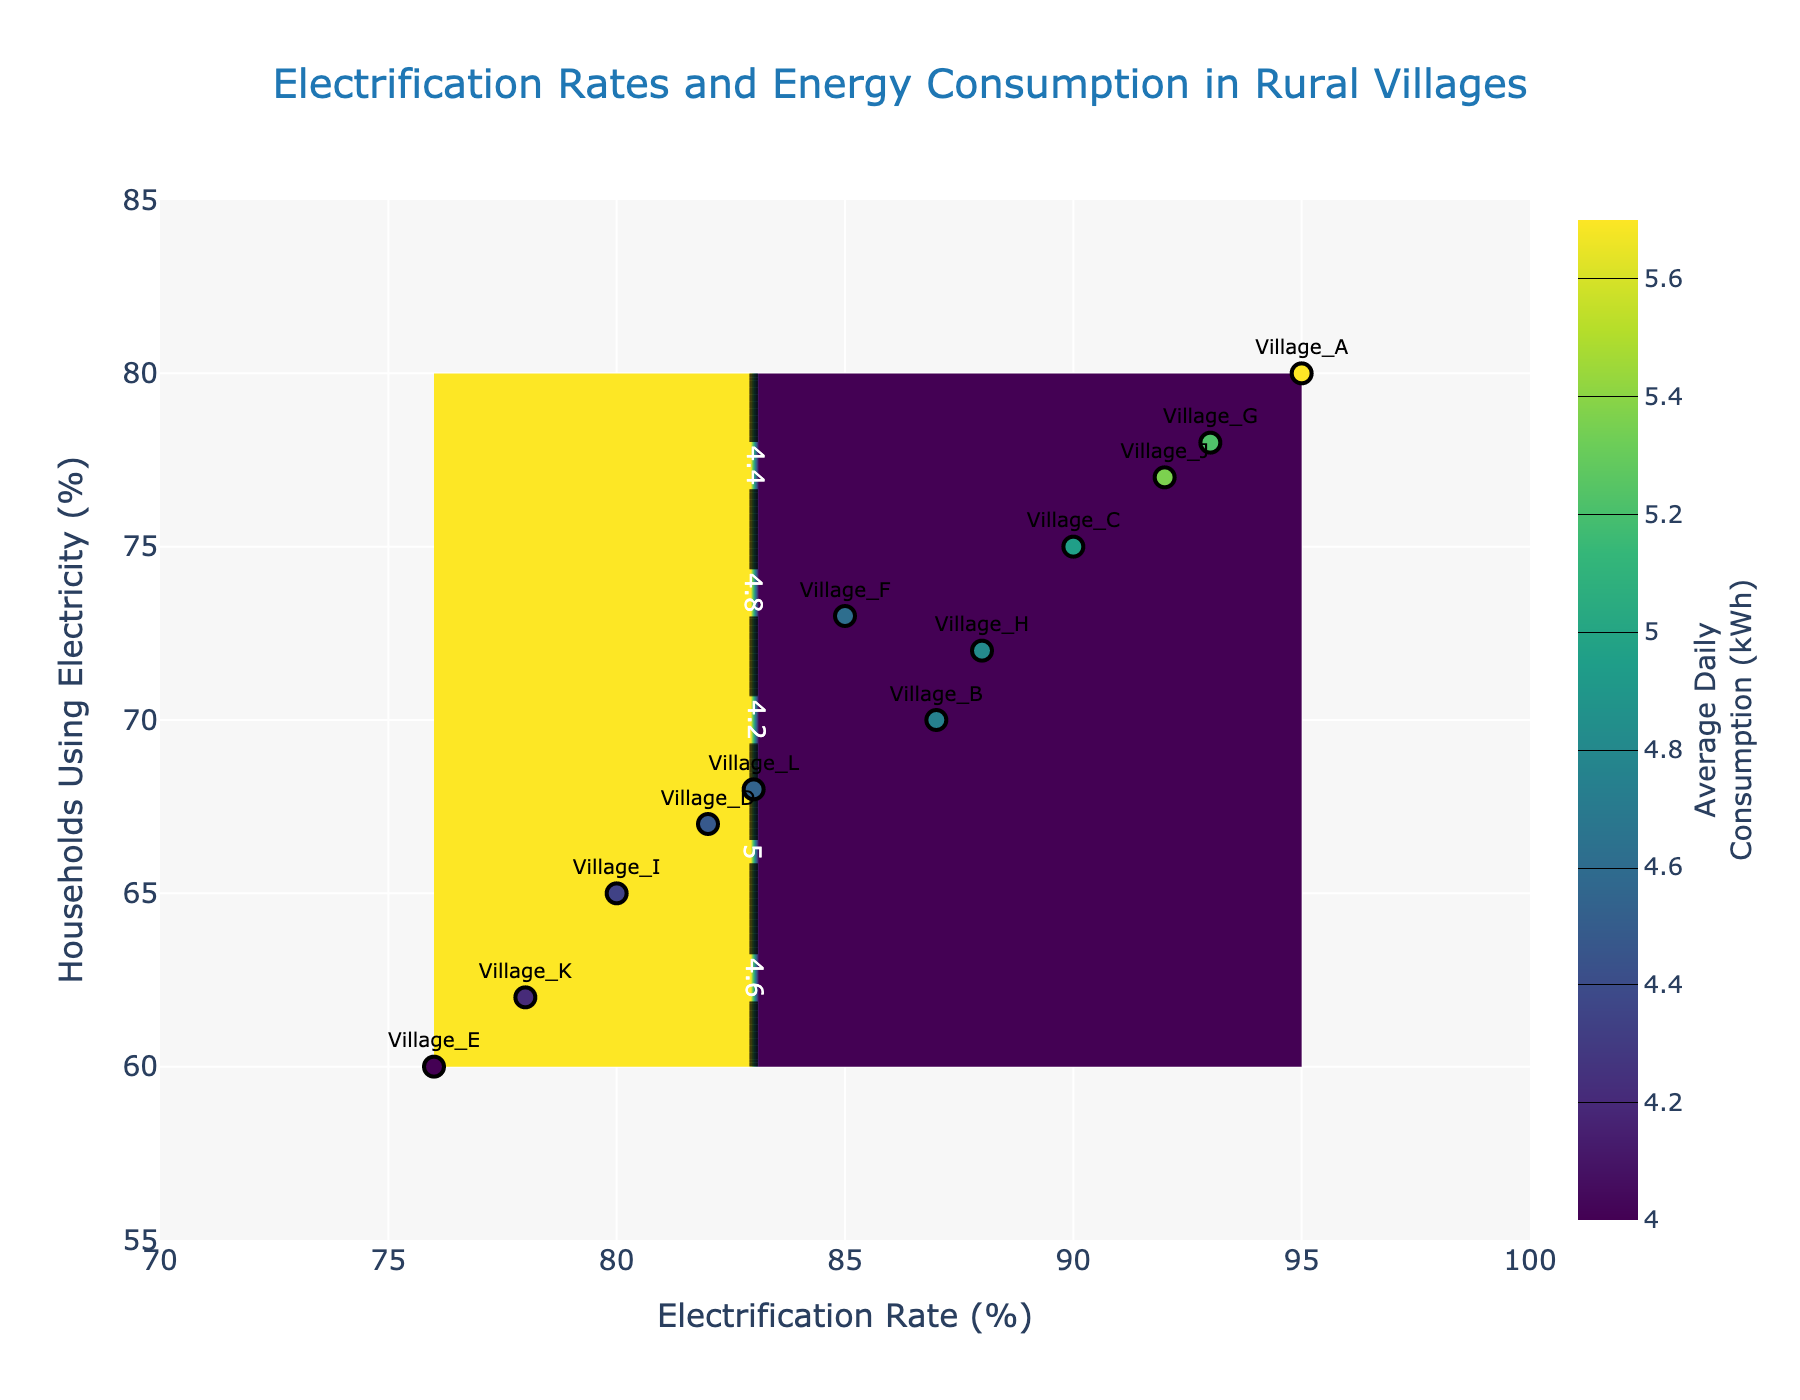What is the title of the plot? The title of a plot is usually displayed prominently at the top. From the rendered figure, we can see the title is centered and is "Electrification Rates and Energy Consumption in Rural Villages".
Answer: Electrification Rates and Energy Consumption in Rural Villages What is the range of the x-axis (Electrification Rate (%))? The x-axis represents the Electrification Rate (%). From the figure, we can see the labels on the x-axis range from 70 to 100%.
Answer: 70 to 100% How many data points are shown on the plot for different villages? Each village corresponds to a point on the scatter plot. By counting the number of markers, we can see there are 12 markers, which match the 12 villages in the dataset.
Answer: 12 Which village has the highest average daily consumption (kWh)? By looking at the markers and the text labels associated with them, the highest value for average daily consumption should be checked. Village_A has the highest value of 5.7 kWh.
Answer: Village_A What is the relationship between Electrification Rate (%) and Households Using Electricity (%) for Village_A? Locate the marker for Village_A and find its position coordinates on the x-axis and y-axis. For Village_A, the Electrification Rate is 95%, and Households Using Electricity is 80%.
Answer: 95% (Electrification Rate), 80% (Households Using Electricity) How does the contour pattern change as the Electrification Rate (%) increases? Observing the contour lines from left (low electrification rate) to right (high electrification rate), we can see the color gradient, which represents varying average daily consumption. Typically, the color becomes darker, indicating higher consumption rates.
Answer: Average daily consumption (kWh) increases with higher Electrification Rate (%) Which village has the lowest usage of electricity among households (Households Using Electricity (%))? By examining the y-axis values and text labels, the village with the lowest Households Using Electricity (%) is identified. Village_E has the lowest value at 60%.
Answer: Village_E Compare the average daily consumption (kWh) between villages with Electrification Rates of 80% and 90%. Locate the markers for villages near the 80% and 90% Electrification Rates and compare their average daily consumption. Village_I and Village_C are examples with 80% and 90% Electrification Rates, having 3.7 kWh and 4.6 kWh, respectively.
Answer: 3.7 kWh (80% Rate), 4.6 kWh (90% Rate) What is the pattern between Households Using Electricity (%) and average daily consumption (kWh) in the plot? Analyze the scatter plot where the coloring indicates the consumption levels. Typically villages with higher Households Using Electricity (%) tend to have higher average daily consumption (kWh). The trend shows a positive relationship between the two variables.
Answer: Higher Households Using Electricity (%) generally leads to higher average daily consumption (kWh) What does the color range in the contour plot represent? The color range in the contour plot represents the values of average daily consumption (kWh). Darker colors usually indicate higher consumption values, as shown by the color bar on the right.
Answer: Average daily consumption (kWh) 